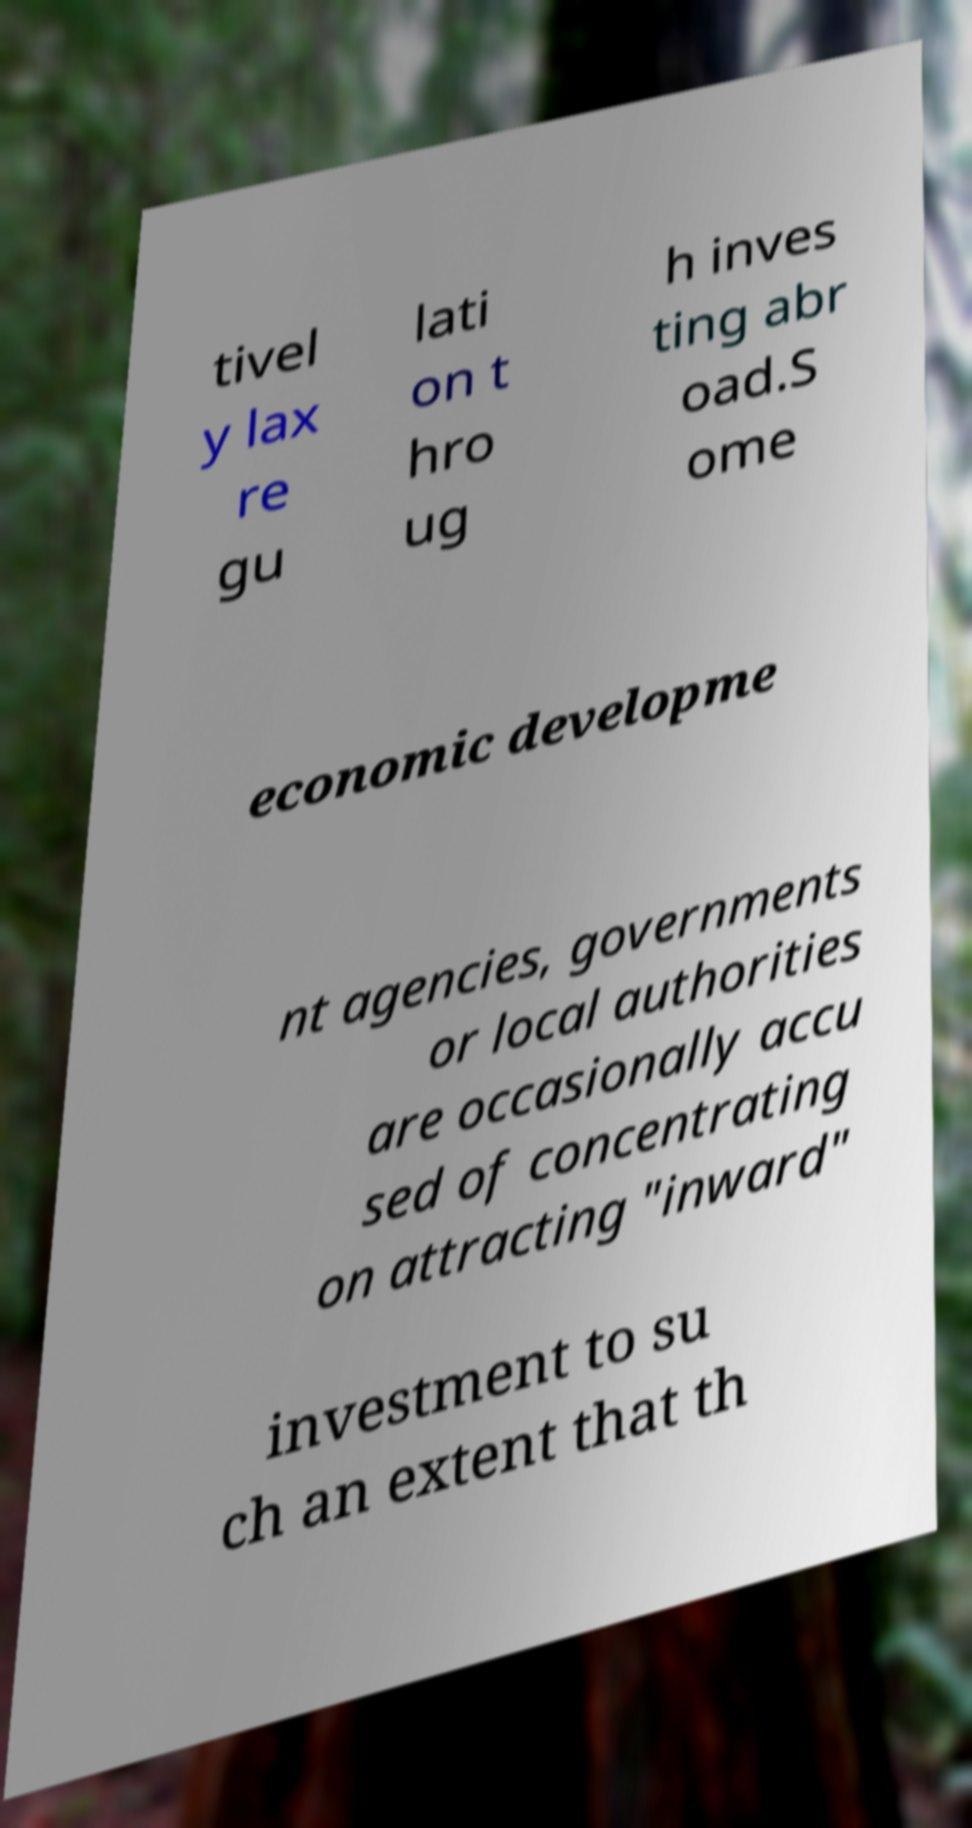I need the written content from this picture converted into text. Can you do that? tivel y lax re gu lati on t hro ug h inves ting abr oad.S ome economic developme nt agencies, governments or local authorities are occasionally accu sed of concentrating on attracting "inward" investment to su ch an extent that th 